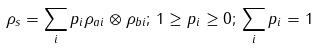<formula> <loc_0><loc_0><loc_500><loc_500>\rho _ { s } = \sum _ { i } p _ { i } \rho _ { a i } \otimes \rho _ { b i } ; \, 1 \geq p _ { i } \geq 0 ; \, \sum _ { i } p _ { i } = 1</formula> 